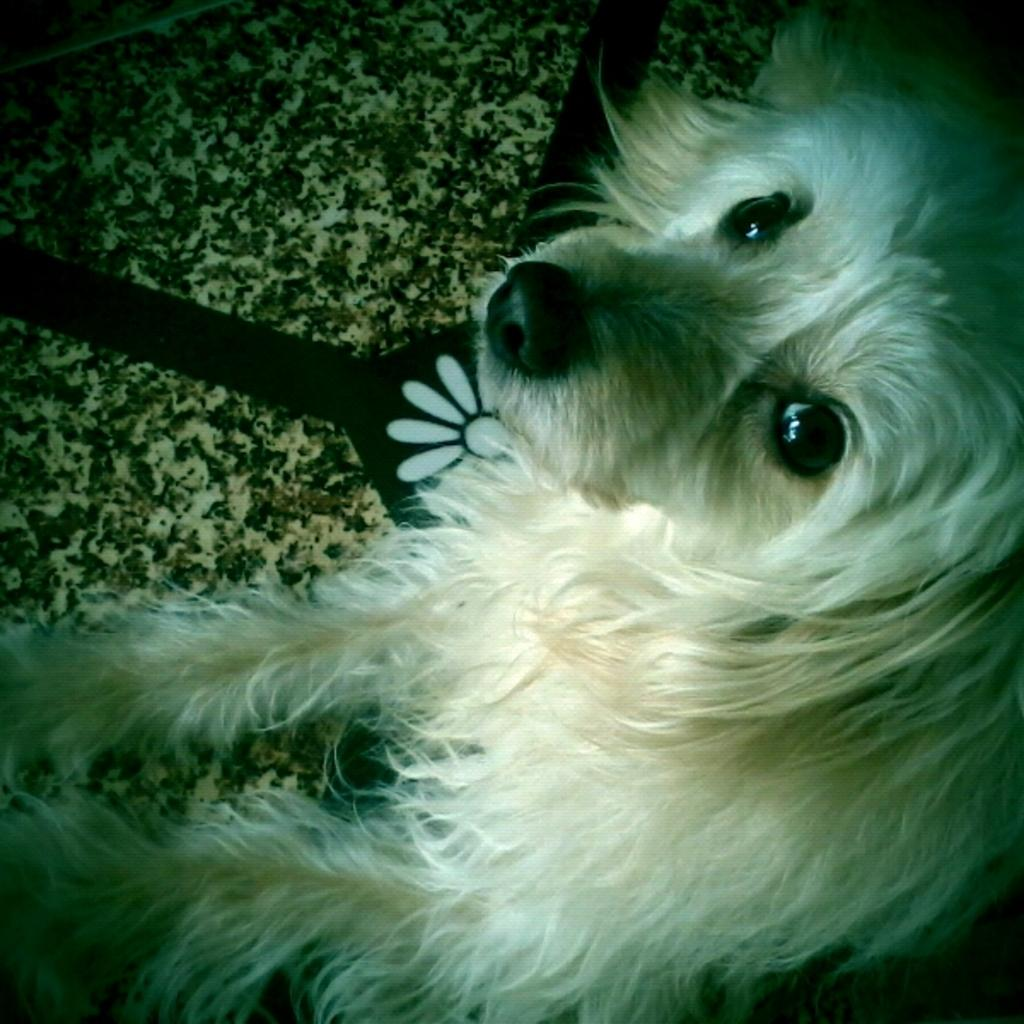What type of animal is present in the image? There is a dog in the image. Where is the dog located in the image? The dog is on the floor. What type of wheel can be seen attached to the dog in the image? There is no wheel attached to the dog in the image. How many needles are visible in the image? There are no needles present in the image. 